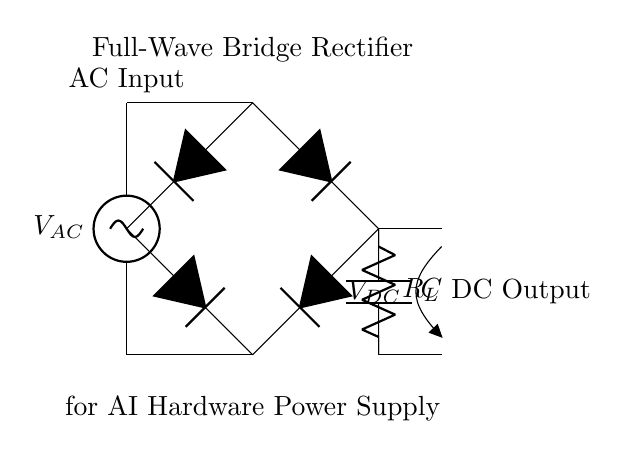What is the type of input voltage for this circuit? The circuit diagram shows an AC voltage source, indicated by the label V_AC, which specifies that the input type is alternating current.
Answer: AC What component smooths the DC output? The smoothing capacitor is identified in the circuit as C, which is connected in parallel with the load resistor to reduce voltage ripples in the output.
Answer: C How many diodes are in the bridge rectifier? The bridge rectifier consists of four diodes, represented in the diagram by D*, which work together to convert the AC input to DC output.
Answer: Four What is the main purpose of this circuit? The circuit's title indicates that it is a full-wave bridge rectifier specifically designed for a power supply, indicating its main purpose is to convert alternating current into a usable direct current for AI hardware.
Answer: Power supply What is the load resistor labeled in the circuit? In the diagram, the load resistor is indicated as R_L, which serves to draw power from the rectified output after conversion, representing the load on the circuit.
Answer: R_L What is the DC output voltage after rectification? The DC output voltage is labeled as V_DC in the schematic. Due to the nature of the bridge rectifier, this output will be a converted voltage that corresponds to the input AC voltage but does not specify an exact value.
Answer: V_DC 